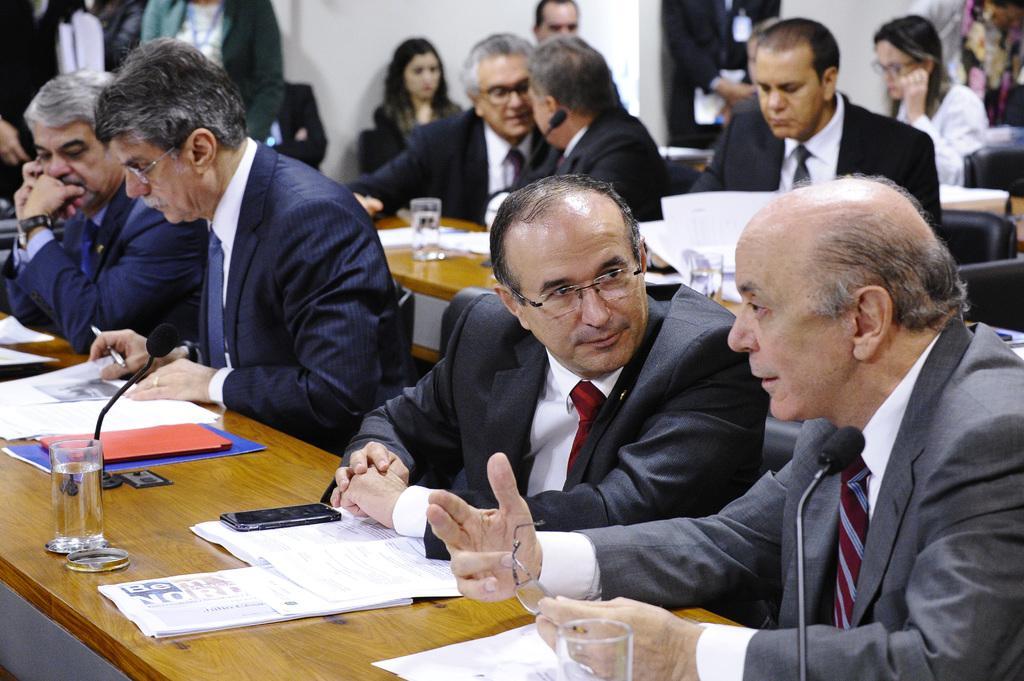Describe this image in one or two sentences. Here few men are sitting on the chairs and talking each other. They wore coats, ties, shirts and there are water glasses on this table. 